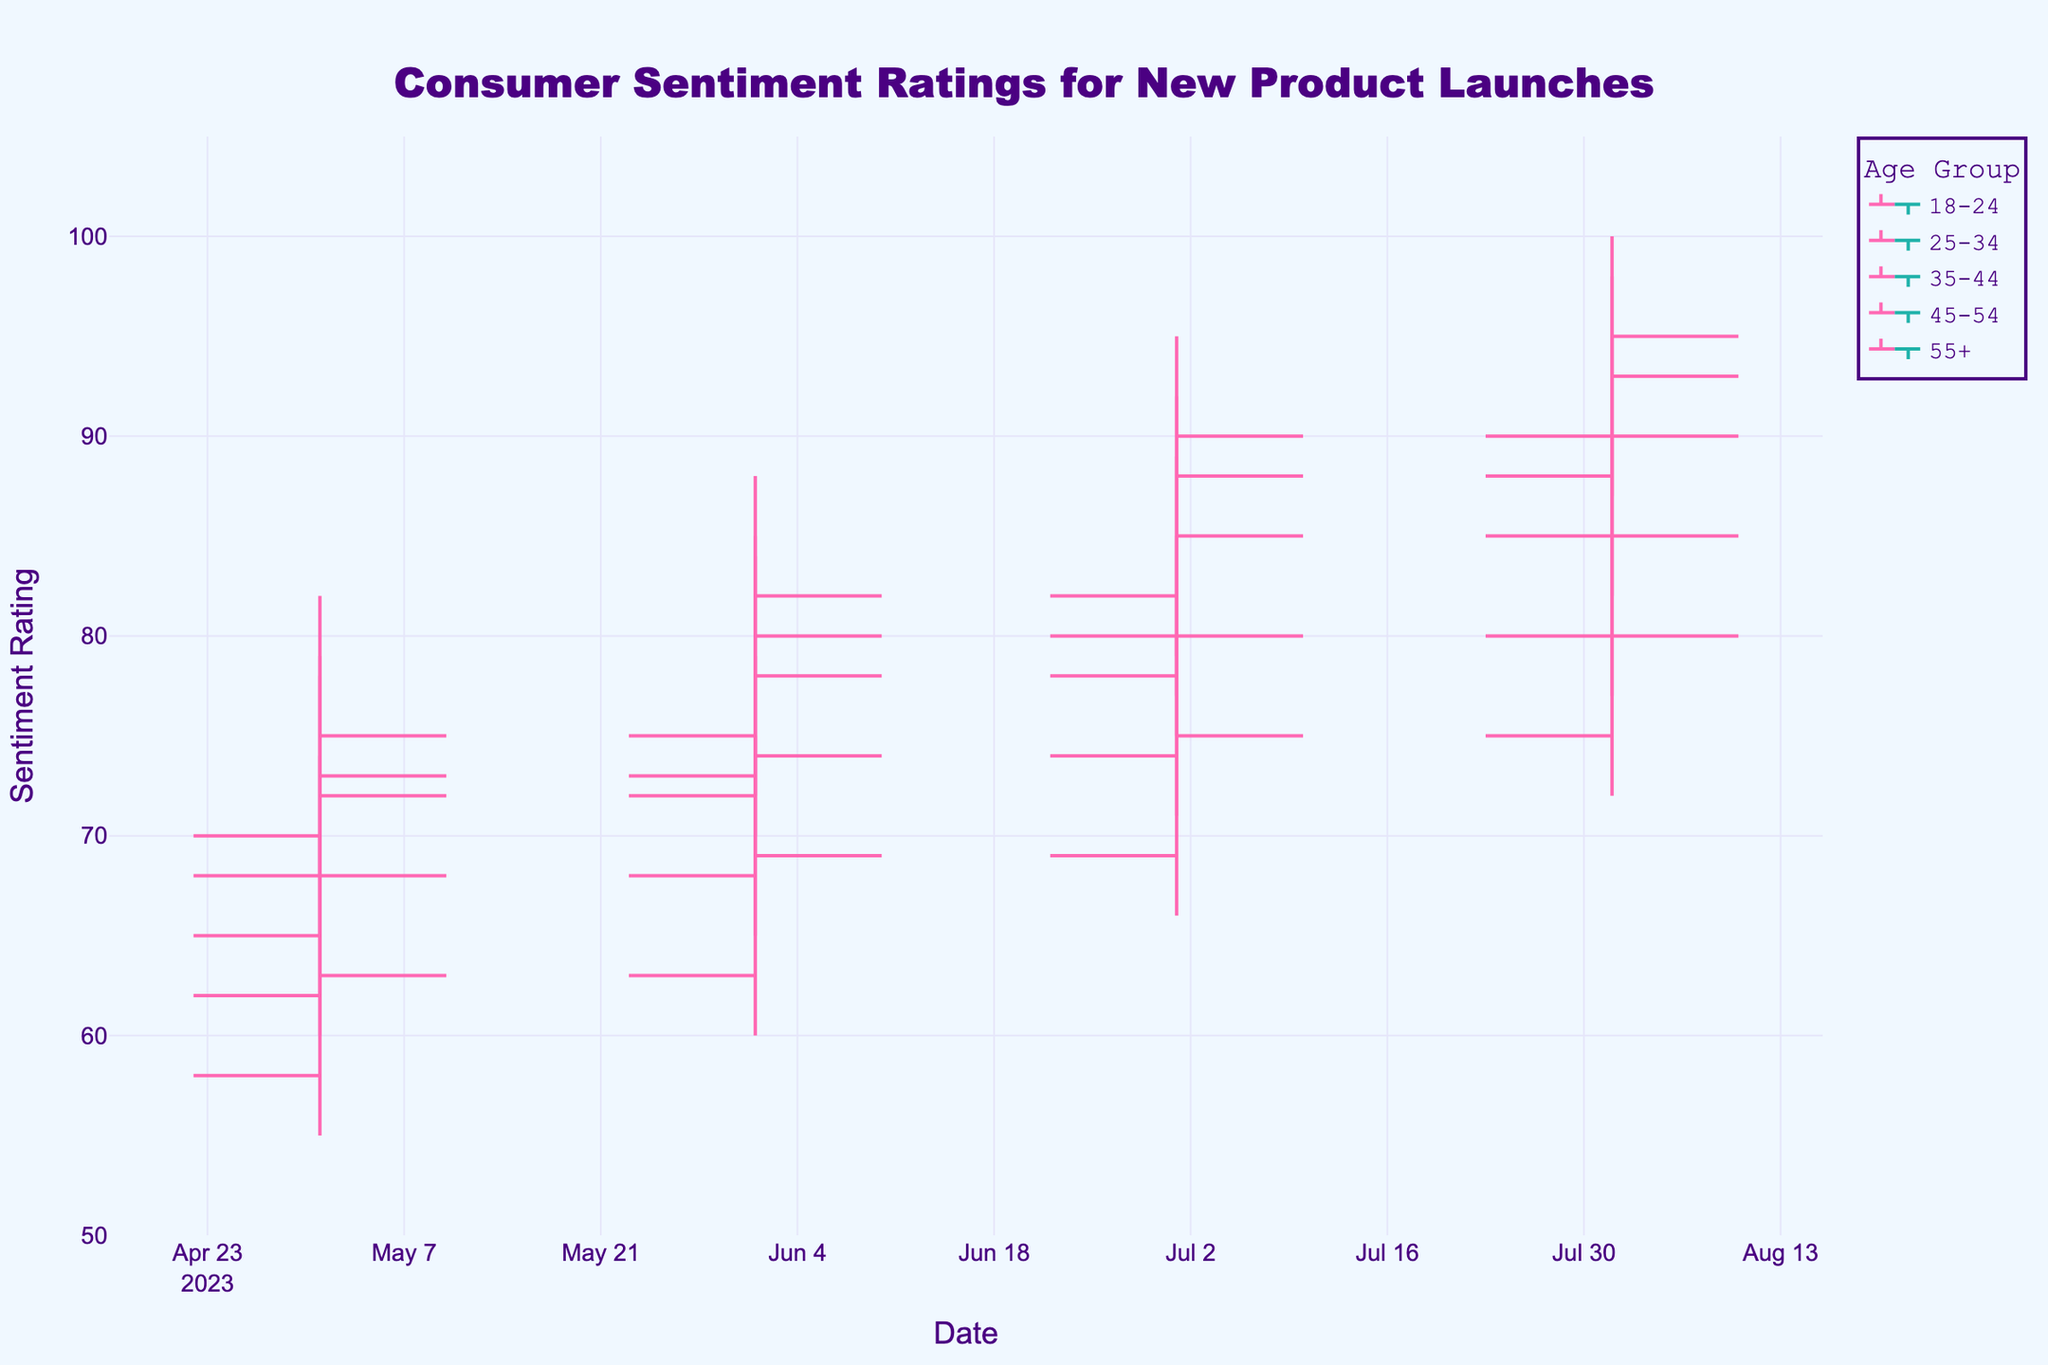What is the title of the figure? The title of the figure is prominently displayed at the top center of the chart.
Answer: Consumer Sentiment Ratings for New Product Launches What color is used for the increasing sentiment line in the 18-24 age group? The color of the increasing sentiment line for each age group is specified in the chart's code as '#FF69B4'. This can be observed in the chart.
Answer: Pink Which age group had the highest closing sentiment rating in August 2023? To answer this, look at the closing sentiment ratings for each age group in August 2023. The 25-34 age group has the highest closing rating of 95.
Answer: 25-34 What is the range of the y-axis in the chart? The y-axis range can be found by reading the y-axis labels. The range is from 50 to 105.
Answer: 50 to 105 In July 2023, what was the difference between the high sentiment rating and the low sentiment rating for the 35-44 age group? Subtract the low rating from the high rating for the 35-44 age group in July 2023: 89 - 75 = 14.
Answer: 14 What is the average closing sentiment rating in August 2023 across all age groups? Add the closing ratings for all age groups in August 2023 (93+95+90+85+80) and divide by the number of age groups (5). Calculation: (93+95+90+85+80)/5 = 88.6.
Answer: 88.6 Which age group experienced an increase in their closing sentiment rating every month from May to August 2023? By examining the closing sentiment ratings for each month for each age group, we see that the 18-24 age group has consistently increasing ratings: 72, 80, 88, 93.
Answer: 18-24 How does the closing sentiment rating for the 55+ age group in August 2023 compare to their closing sentiment rating in May 2023? Compare the closing ratings: August (80) - May (63) = 17. The rating increased by 17 points.
Answer: Increased by 17 points What was the highest sentiment rating recorded in June 2023 and which age group did it belong to? From the data, the highest sentiment rating in June 2023 was 88, which belongs to the 25-34 age group.
Answer: 88, 25-34 